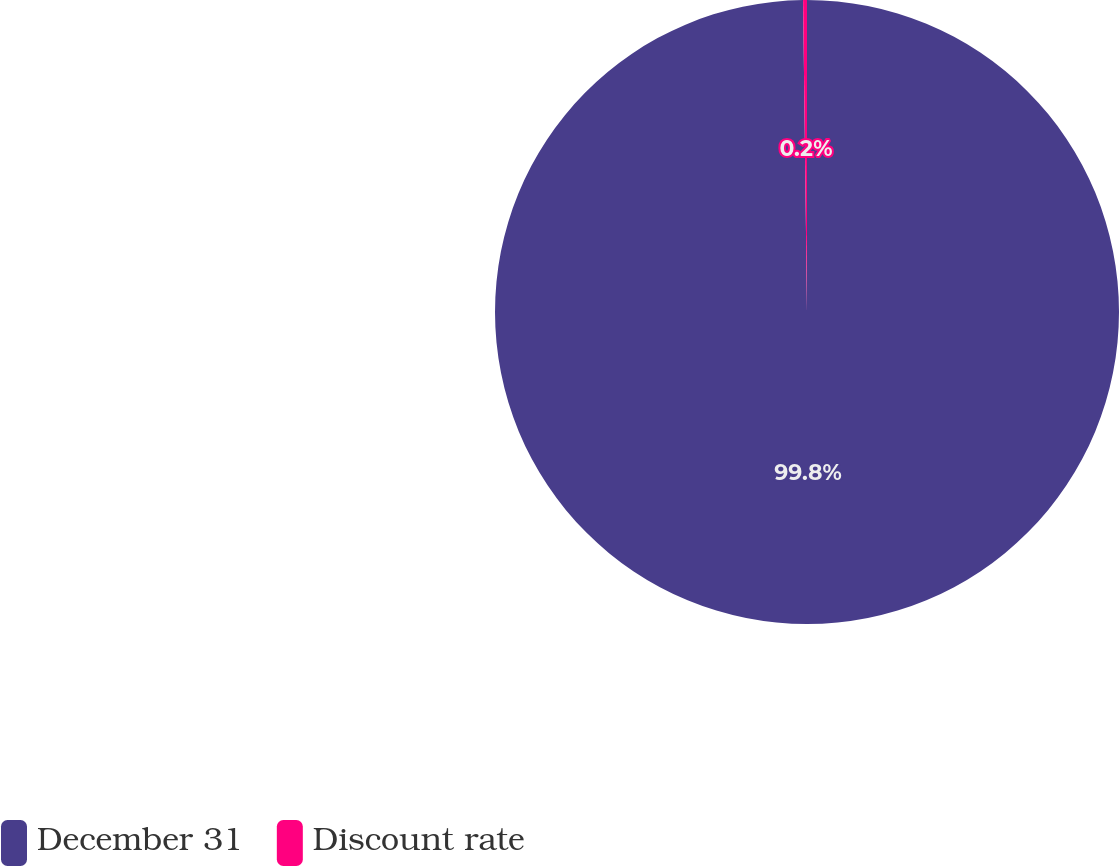Convert chart to OTSL. <chart><loc_0><loc_0><loc_500><loc_500><pie_chart><fcel>December 31<fcel>Discount rate<nl><fcel>99.8%<fcel>0.2%<nl></chart> 